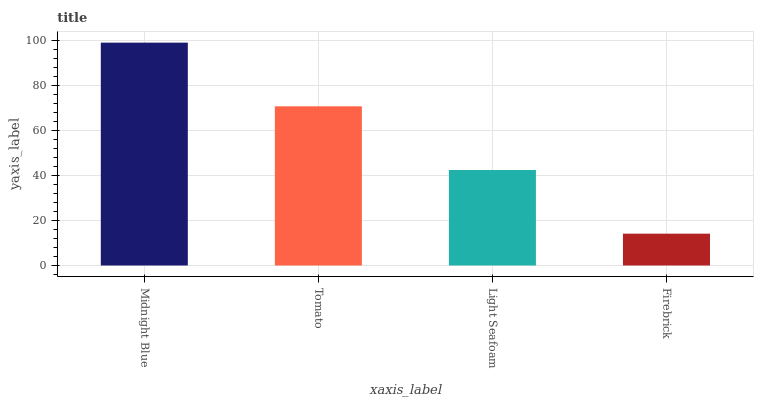Is Firebrick the minimum?
Answer yes or no. Yes. Is Midnight Blue the maximum?
Answer yes or no. Yes. Is Tomato the minimum?
Answer yes or no. No. Is Tomato the maximum?
Answer yes or no. No. Is Midnight Blue greater than Tomato?
Answer yes or no. Yes. Is Tomato less than Midnight Blue?
Answer yes or no. Yes. Is Tomato greater than Midnight Blue?
Answer yes or no. No. Is Midnight Blue less than Tomato?
Answer yes or no. No. Is Tomato the high median?
Answer yes or no. Yes. Is Light Seafoam the low median?
Answer yes or no. Yes. Is Midnight Blue the high median?
Answer yes or no. No. Is Midnight Blue the low median?
Answer yes or no. No. 